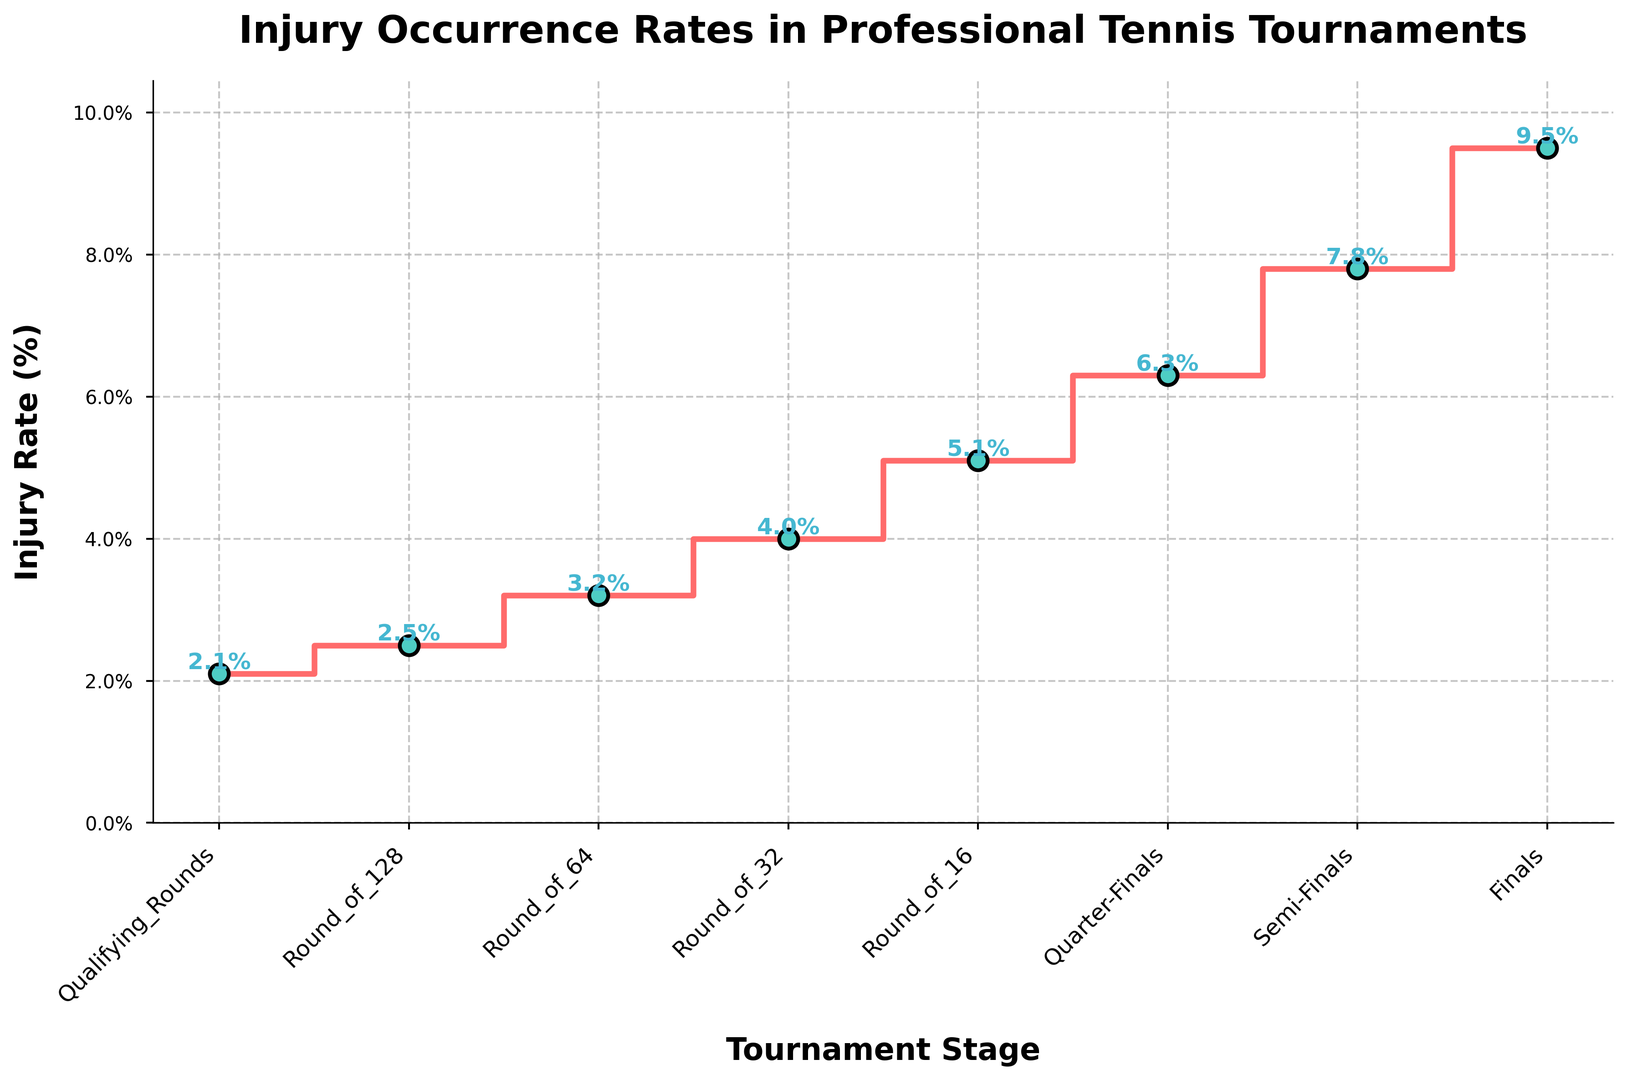What is the injury rate at the Semi-Finals stage? The injury rate at the Semi-Finals stage can be read directly from the figure. By looking at the x-axis for the Semi-Finals label and then referring up to the corresponding y-axis value, we can see that it's 7.8%.
Answer: 7.8% How much higher is the injury rate in the Finals compared to the Qualifying Rounds? Subtract the injury rate in the Qualifying Rounds from the injury rate in the Finals. The Finals has a rate of 9.5% and the Qualifying Rounds has a rate of 2.1%, so 9.5% - 2.1% = 7.4%.
Answer: 7.4% Which tournament stage shows the highest injury rate? The highest point in the figure corresponds to the Finals stage. By identifying the tallest step and checking its label, the Finals stage has the highest injury rate at 9.5%.
Answer: Finals What is the total increase in injury rate from the Round of 128 to the Finals? Calculate the difference between each consecutive stage from the Round of 128 (2.5%) to the Finals (9.5%). Add these individual differences: (3.2% - 2.5%) + (4.0% - 3.2%) + (5.1% - 4.0%) + (6.3% - 5.1%) + (7.8% - 6.3%) + (9.5% - 7.8%) = 0.7% + 0.8% + 1.1% + 1.2% + 1.5% + 1.7% = 7.0%.
Answer: 7.0% Which two consecutive stages show the largest increase in injury rates? Observe the differences between consecutive stages and identify the largest difference. The largest increase occurs between the Semi-Finals and Finals: 9.5% - 7.8% = 1.7%.
Answer: Semi-Finals to Finals How does the injury rate change as players progress from the Round of 16 to the Finals visually? Visually, one can see that the height of the steps increases as players progress from the Round of 16 to the Finals. Each step represents an increase in the injury rate, and the steps become taller.
Answer: Increases What is the average injury rate from the Qualifying Rounds to the Finals? Add all the injury rates from each stage and divide by the number of stages. (2.1% + 2.5% + 3.2% + 4.0% + 5.1% + 6.3% + 7.8% + 9.5%) / 8 stages = 40.5% / 8 = 5.0625%.
Answer: 5.1% Is the injury rate more than double from the first to the last stage? Compare double the injury rate of the first stage with the last stage's injury rate. Double the rate of the Qualifying Rounds (2.1%) is 4.2%. The Finals stage has a rate of 9.5%, which is more than double.
Answer: Yes What is the median injury rate across all tournament stages? Order the injury rates and find the middle value(s). The ordered rates are: 2.1%, 2.5%, 3.2%, 4.0%, 5.1%, 6.3%, 7.8%, 9.5%. Since there are 8 values, the median is the average of the 4th and 5th values: (4.0% + 5.1%) / 2 = 4.55%.
Answer: 4.55% 